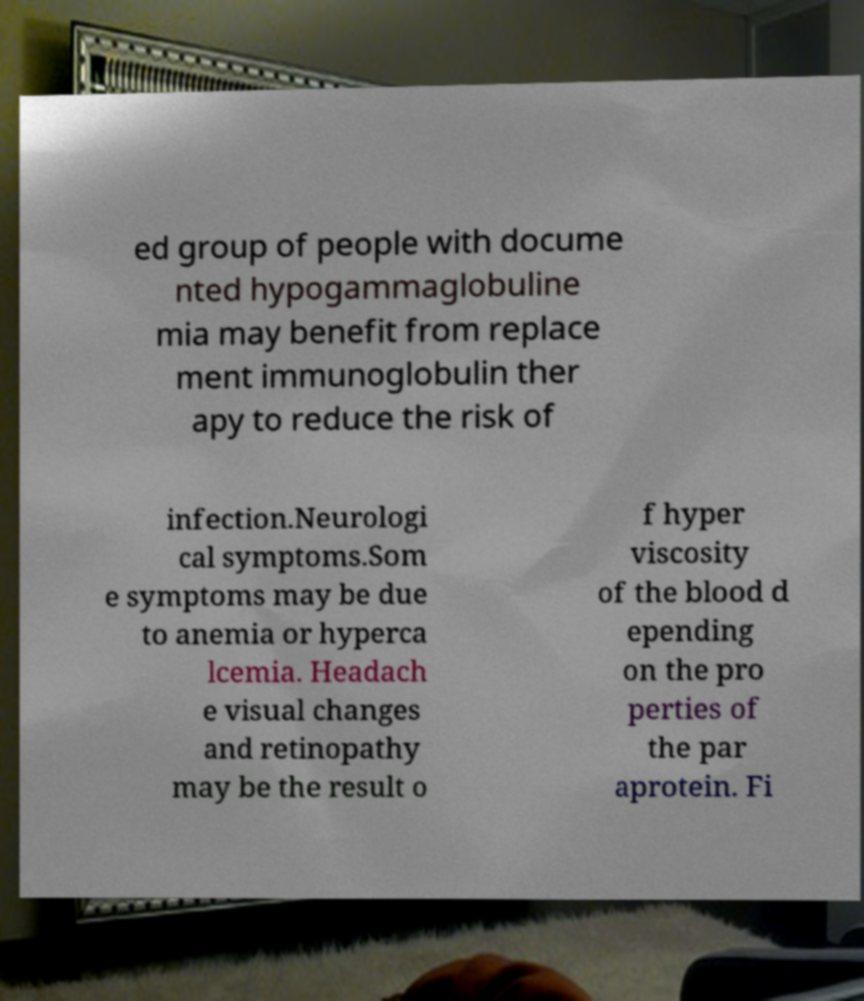Please identify and transcribe the text found in this image. ed group of people with docume nted hypogammaglobuline mia may benefit from replace ment immunoglobulin ther apy to reduce the risk of infection.Neurologi cal symptoms.Som e symptoms may be due to anemia or hyperca lcemia. Headach e visual changes and retinopathy may be the result o f hyper viscosity of the blood d epending on the pro perties of the par aprotein. Fi 